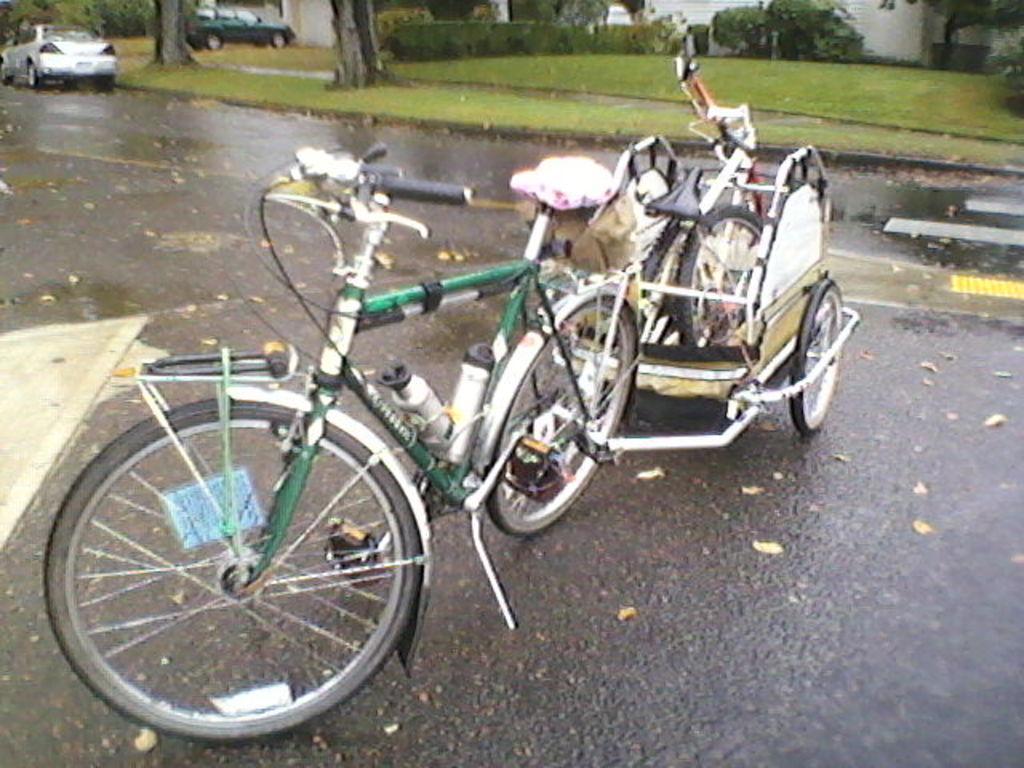In one or two sentences, can you explain what this image depicts? In the center of the image there is a bicycle with a cart attached to it. At the bottom of the image there is road. In the background of the image there are cars,trees,grass. 